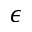Convert formula to latex. <formula><loc_0><loc_0><loc_500><loc_500>\epsilon</formula> 